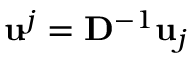Convert formula to latex. <formula><loc_0><loc_0><loc_500><loc_500>u ^ { j } = D ^ { - 1 } u _ { j }</formula> 